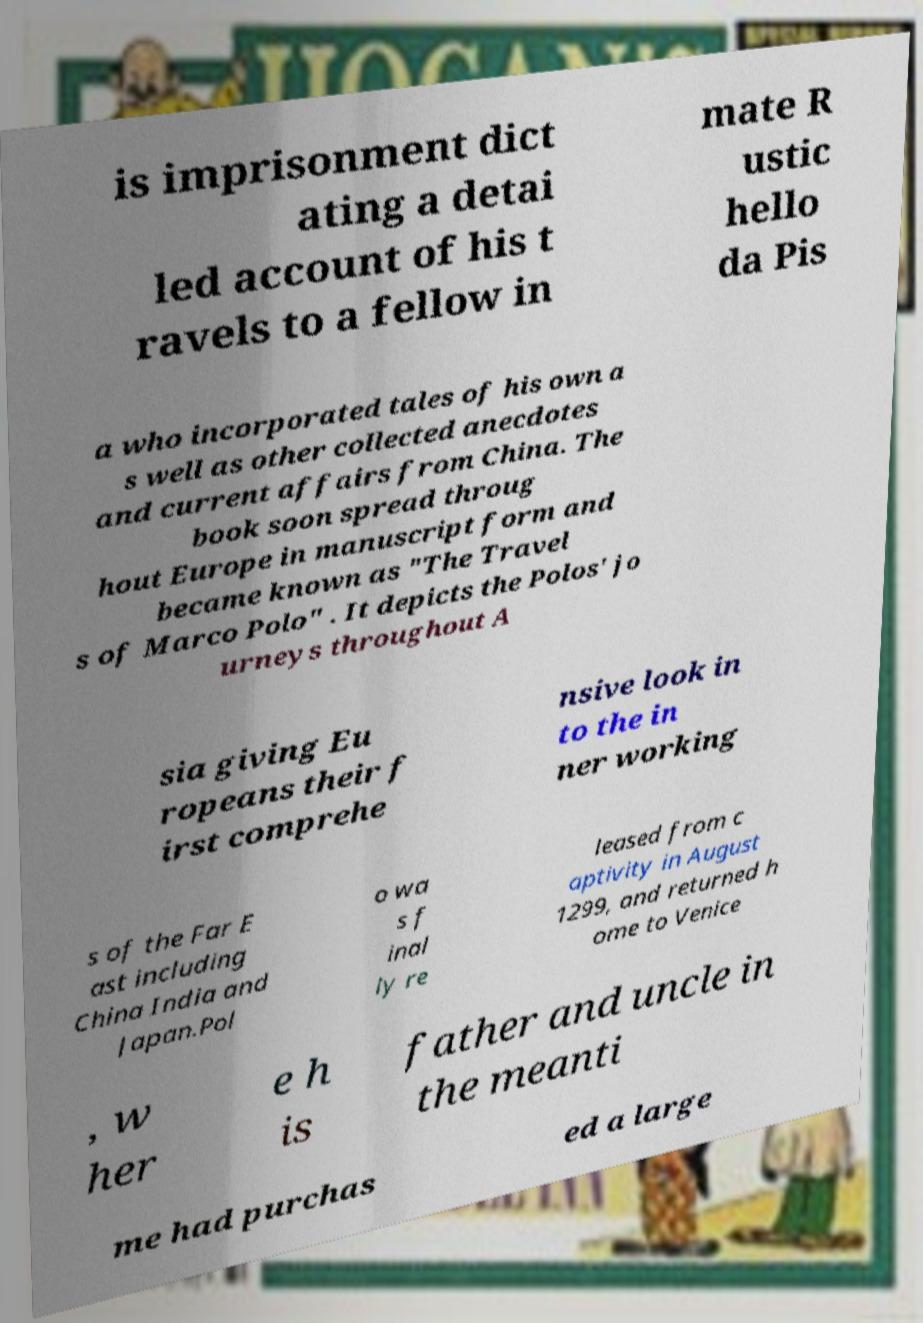Could you extract and type out the text from this image? is imprisonment dict ating a detai led account of his t ravels to a fellow in mate R ustic hello da Pis a who incorporated tales of his own a s well as other collected anecdotes and current affairs from China. The book soon spread throug hout Europe in manuscript form and became known as "The Travel s of Marco Polo" . It depicts the Polos' jo urneys throughout A sia giving Eu ropeans their f irst comprehe nsive look in to the in ner working s of the Far E ast including China India and Japan.Pol o wa s f inal ly re leased from c aptivity in August 1299, and returned h ome to Venice , w her e h is father and uncle in the meanti me had purchas ed a large 